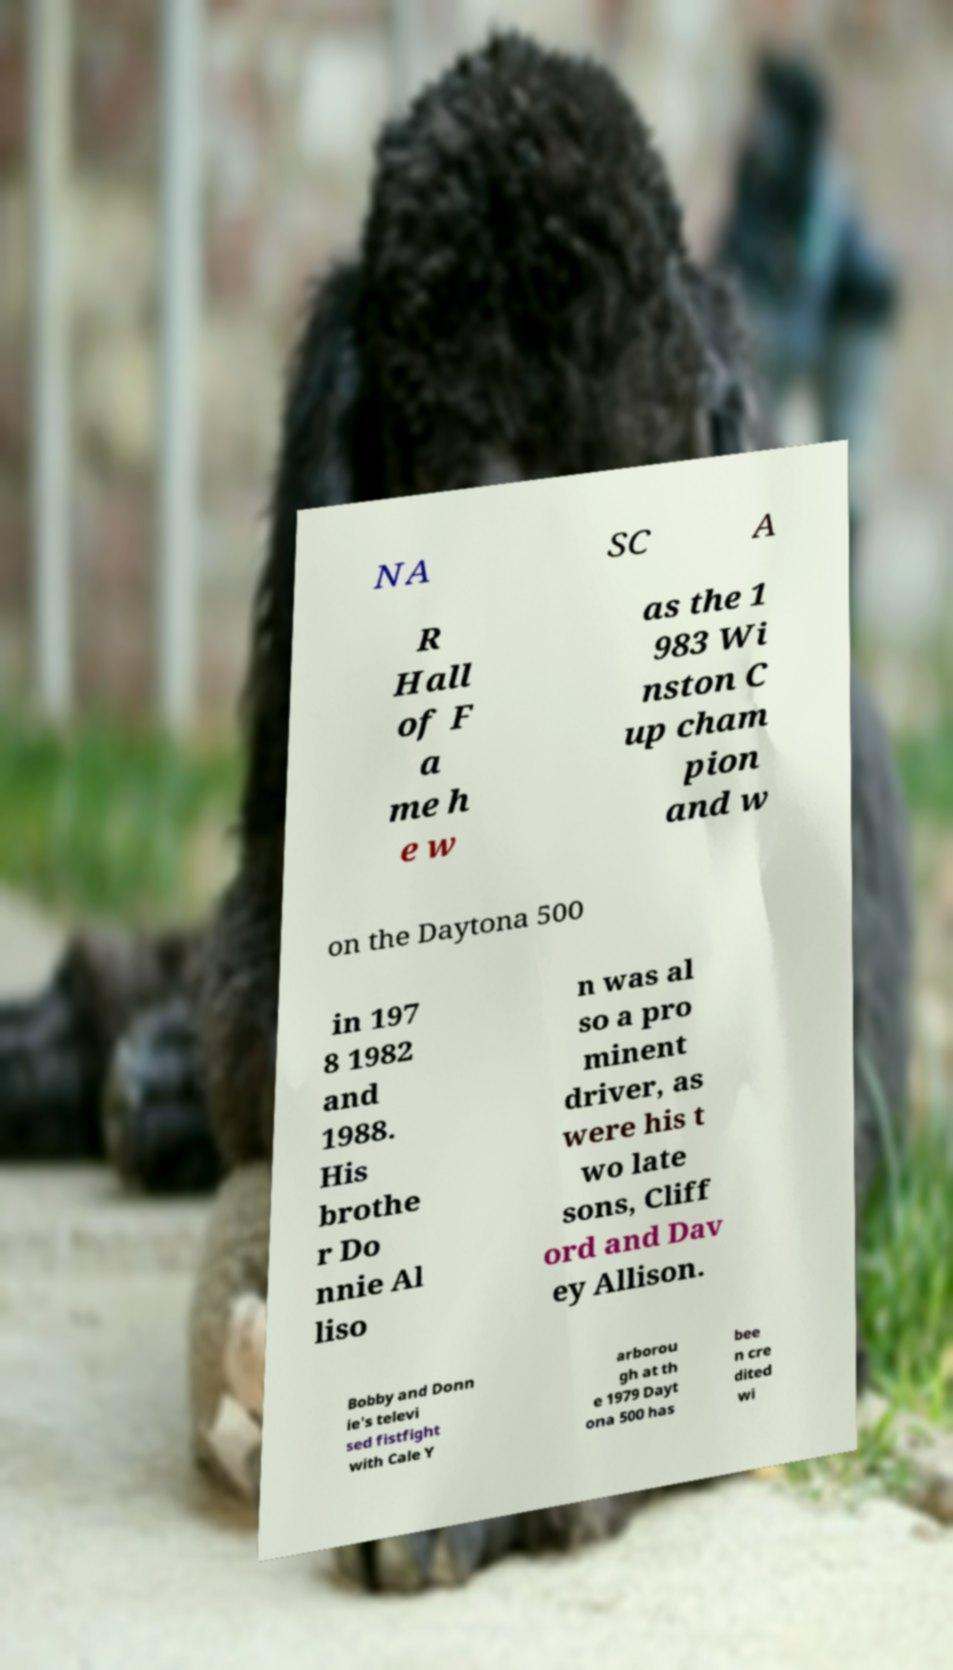Please identify and transcribe the text found in this image. NA SC A R Hall of F a me h e w as the 1 983 Wi nston C up cham pion and w on the Daytona 500 in 197 8 1982 and 1988. His brothe r Do nnie Al liso n was al so a pro minent driver, as were his t wo late sons, Cliff ord and Dav ey Allison. Bobby and Donn ie's televi sed fistfight with Cale Y arborou gh at th e 1979 Dayt ona 500 has bee n cre dited wi 